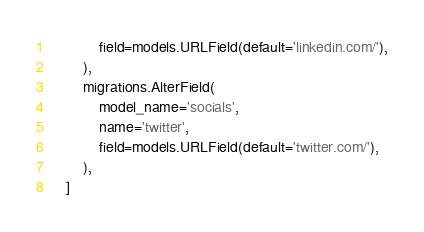<code> <loc_0><loc_0><loc_500><loc_500><_Python_>            field=models.URLField(default='linkedin.com/'),
        ),
        migrations.AlterField(
            model_name='socials',
            name='twitter',
            field=models.URLField(default='twitter.com/'),
        ),
    ]
</code> 